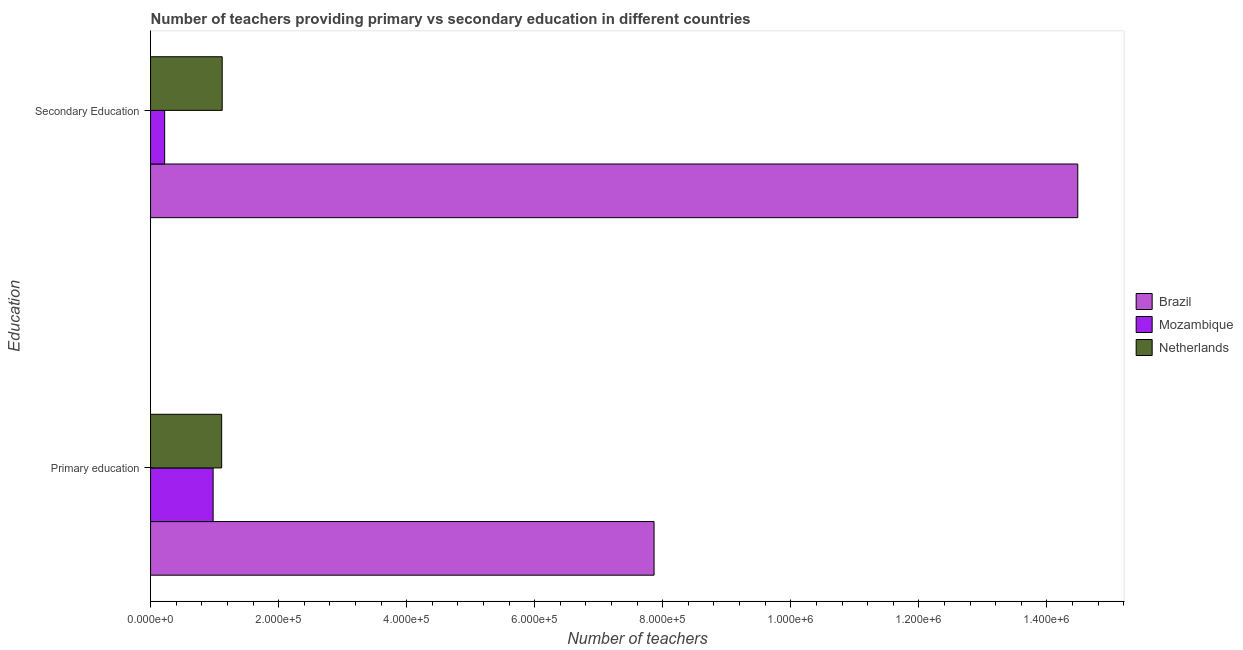How many groups of bars are there?
Your answer should be compact. 2. What is the label of the 1st group of bars from the top?
Offer a very short reply. Secondary Education. What is the number of primary teachers in Brazil?
Give a very brief answer. 7.86e+05. Across all countries, what is the maximum number of primary teachers?
Offer a very short reply. 7.86e+05. Across all countries, what is the minimum number of primary teachers?
Your answer should be very brief. 9.77e+04. In which country was the number of secondary teachers maximum?
Provide a succinct answer. Brazil. In which country was the number of primary teachers minimum?
Keep it short and to the point. Mozambique. What is the total number of primary teachers in the graph?
Your answer should be compact. 9.95e+05. What is the difference between the number of primary teachers in Mozambique and that in Netherlands?
Offer a terse response. -1.33e+04. What is the difference between the number of secondary teachers in Netherlands and the number of primary teachers in Mozambique?
Ensure brevity in your answer.  1.42e+04. What is the average number of primary teachers per country?
Offer a very short reply. 3.32e+05. What is the difference between the number of secondary teachers and number of primary teachers in Netherlands?
Keep it short and to the point. 831. In how many countries, is the number of primary teachers greater than 280000 ?
Ensure brevity in your answer.  1. What is the ratio of the number of primary teachers in Netherlands to that in Brazil?
Ensure brevity in your answer.  0.14. Is the number of secondary teachers in Netherlands less than that in Mozambique?
Offer a very short reply. No. What does the 2nd bar from the top in Primary education represents?
Ensure brevity in your answer.  Mozambique. What does the 2nd bar from the bottom in Primary education represents?
Keep it short and to the point. Mozambique. How many bars are there?
Provide a succinct answer. 6. Are the values on the major ticks of X-axis written in scientific E-notation?
Offer a terse response. Yes. Does the graph contain any zero values?
Provide a short and direct response. No. How are the legend labels stacked?
Provide a short and direct response. Vertical. What is the title of the graph?
Your answer should be compact. Number of teachers providing primary vs secondary education in different countries. Does "Turkmenistan" appear as one of the legend labels in the graph?
Offer a very short reply. No. What is the label or title of the X-axis?
Keep it short and to the point. Number of teachers. What is the label or title of the Y-axis?
Provide a short and direct response. Education. What is the Number of teachers of Brazil in Primary education?
Your answer should be compact. 7.86e+05. What is the Number of teachers in Mozambique in Primary education?
Provide a short and direct response. 9.77e+04. What is the Number of teachers in Netherlands in Primary education?
Keep it short and to the point. 1.11e+05. What is the Number of teachers in Brazil in Secondary Education?
Offer a terse response. 1.45e+06. What is the Number of teachers in Mozambique in Secondary Education?
Provide a succinct answer. 2.20e+04. What is the Number of teachers of Netherlands in Secondary Education?
Give a very brief answer. 1.12e+05. Across all Education, what is the maximum Number of teachers of Brazil?
Your answer should be very brief. 1.45e+06. Across all Education, what is the maximum Number of teachers in Mozambique?
Provide a succinct answer. 9.77e+04. Across all Education, what is the maximum Number of teachers of Netherlands?
Give a very brief answer. 1.12e+05. Across all Education, what is the minimum Number of teachers in Brazil?
Give a very brief answer. 7.86e+05. Across all Education, what is the minimum Number of teachers in Mozambique?
Offer a very short reply. 2.20e+04. Across all Education, what is the minimum Number of teachers in Netherlands?
Ensure brevity in your answer.  1.11e+05. What is the total Number of teachers in Brazil in the graph?
Keep it short and to the point. 2.23e+06. What is the total Number of teachers of Mozambique in the graph?
Keep it short and to the point. 1.20e+05. What is the total Number of teachers in Netherlands in the graph?
Ensure brevity in your answer.  2.23e+05. What is the difference between the Number of teachers of Brazil in Primary education and that in Secondary Education?
Offer a very short reply. -6.62e+05. What is the difference between the Number of teachers of Mozambique in Primary education and that in Secondary Education?
Give a very brief answer. 7.57e+04. What is the difference between the Number of teachers in Netherlands in Primary education and that in Secondary Education?
Offer a terse response. -831. What is the difference between the Number of teachers in Brazil in Primary education and the Number of teachers in Mozambique in Secondary Education?
Ensure brevity in your answer.  7.64e+05. What is the difference between the Number of teachers in Brazil in Primary education and the Number of teachers in Netherlands in Secondary Education?
Provide a succinct answer. 6.75e+05. What is the difference between the Number of teachers in Mozambique in Primary education and the Number of teachers in Netherlands in Secondary Education?
Offer a terse response. -1.42e+04. What is the average Number of teachers in Brazil per Education?
Offer a terse response. 1.12e+06. What is the average Number of teachers in Mozambique per Education?
Your answer should be compact. 5.99e+04. What is the average Number of teachers in Netherlands per Education?
Ensure brevity in your answer.  1.11e+05. What is the difference between the Number of teachers in Brazil and Number of teachers in Mozambique in Primary education?
Keep it short and to the point. 6.89e+05. What is the difference between the Number of teachers of Brazil and Number of teachers of Netherlands in Primary education?
Give a very brief answer. 6.75e+05. What is the difference between the Number of teachers of Mozambique and Number of teachers of Netherlands in Primary education?
Make the answer very short. -1.33e+04. What is the difference between the Number of teachers in Brazil and Number of teachers in Mozambique in Secondary Education?
Your answer should be compact. 1.43e+06. What is the difference between the Number of teachers in Brazil and Number of teachers in Netherlands in Secondary Education?
Ensure brevity in your answer.  1.34e+06. What is the difference between the Number of teachers of Mozambique and Number of teachers of Netherlands in Secondary Education?
Offer a very short reply. -8.99e+04. What is the ratio of the Number of teachers of Brazil in Primary education to that in Secondary Education?
Ensure brevity in your answer.  0.54. What is the ratio of the Number of teachers in Mozambique in Primary education to that in Secondary Education?
Your answer should be compact. 4.44. What is the difference between the highest and the second highest Number of teachers in Brazil?
Your answer should be very brief. 6.62e+05. What is the difference between the highest and the second highest Number of teachers in Mozambique?
Provide a succinct answer. 7.57e+04. What is the difference between the highest and the second highest Number of teachers of Netherlands?
Provide a succinct answer. 831. What is the difference between the highest and the lowest Number of teachers in Brazil?
Offer a very short reply. 6.62e+05. What is the difference between the highest and the lowest Number of teachers of Mozambique?
Offer a very short reply. 7.57e+04. What is the difference between the highest and the lowest Number of teachers in Netherlands?
Keep it short and to the point. 831. 